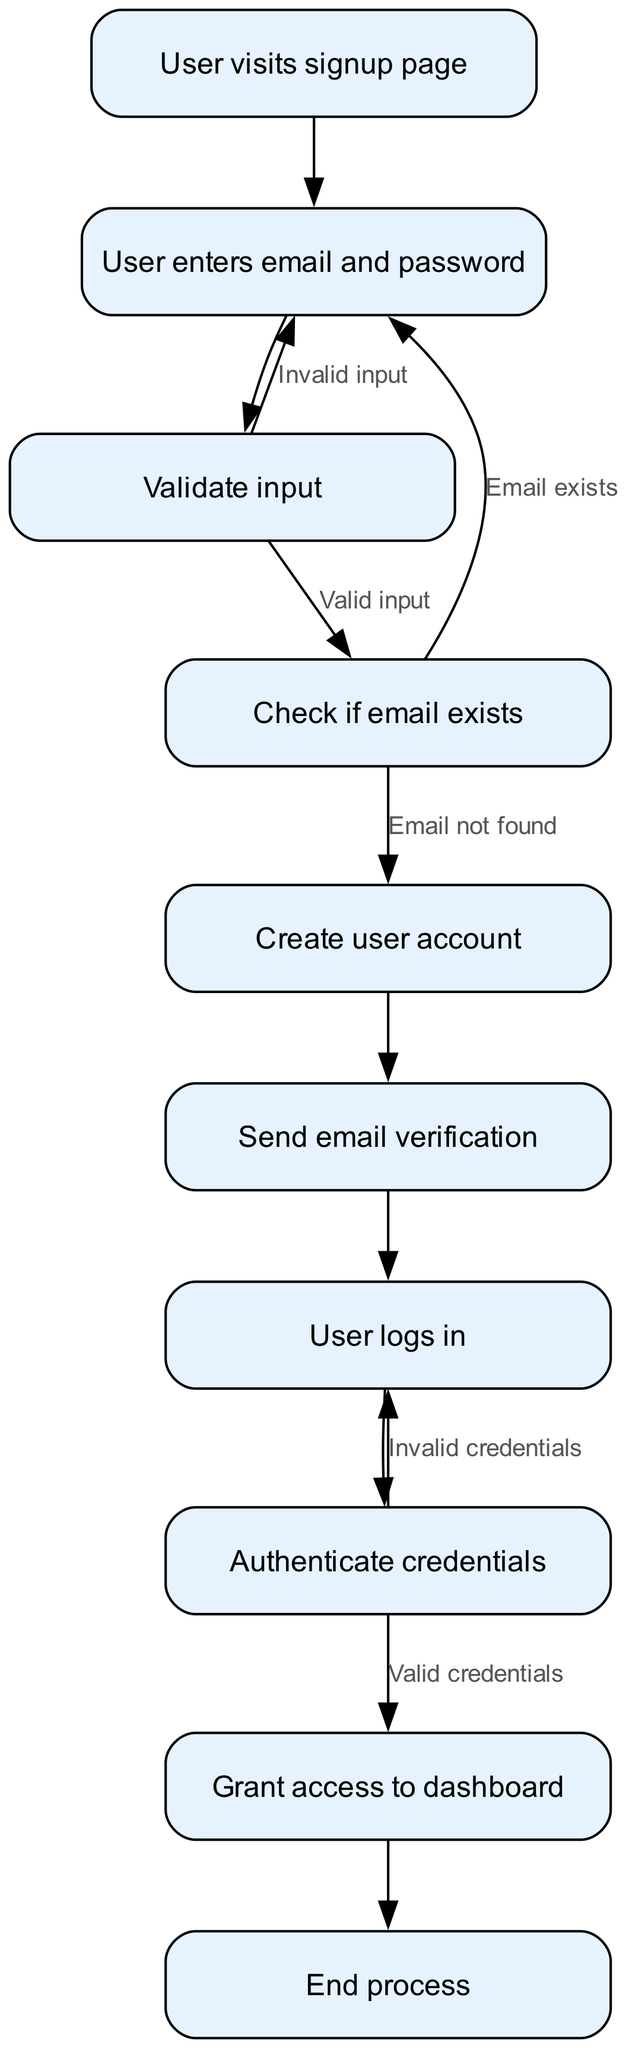What is the first step in the process? The diagram starts with the node "User visits signup page", indicating it is the first action taken by the user.
Answer: User visits signup page How many nodes are in the diagram? The diagram lists a total of 10 nodes, including all actions and endpoints displayed in the flowchart.
Answer: 10 What happens if the user enters invalid input? If the input validation fails, the flowchart indicates that the user will be redirected back to the "User enters email and password" node to retry submitting their information.
Answer: Invalid input What does the process lead to after "Authenticate credentials"? Once the credentials are successfully authenticated, the next step is to "Grant access to dashboard", meaning the user will gain entry to their account.
Answer: Grant access to dashboard What does the "Check if email exists" node lead to if the email is not found? The flow from "Check if email exists" to "Create user account" indicates that the process continues to account creation if the email submitted is not already registered in the system.
Answer: Create user account What will happen if the user provides invalid credentials during login? If the user logs in with invalid credentials, the flowchart indicates a return to the "User logs in" node, prompting the user to enter their credentials again for reattempting login.
Answer: Invalid credentials What action is taken after sending the email verification? After the "Send email verification" step, the flow proceeds to the "User logs in", indicating that the user is expected to attempt logging into their account following the verification email being sent.
Answer: User logs in How many outgoing edges are from the "auth" node? The "auth" node has two outgoing edges: one leading to "access granted" (for valid credentials) and another going back to "login" (for invalid credentials).
Answer: 2 What action is performed if the email entered already exists? The flowchart shows that if the email exists, the user is directed back to the input step, allowing them to enter a different email or correct their input.
Answer: Email exists 